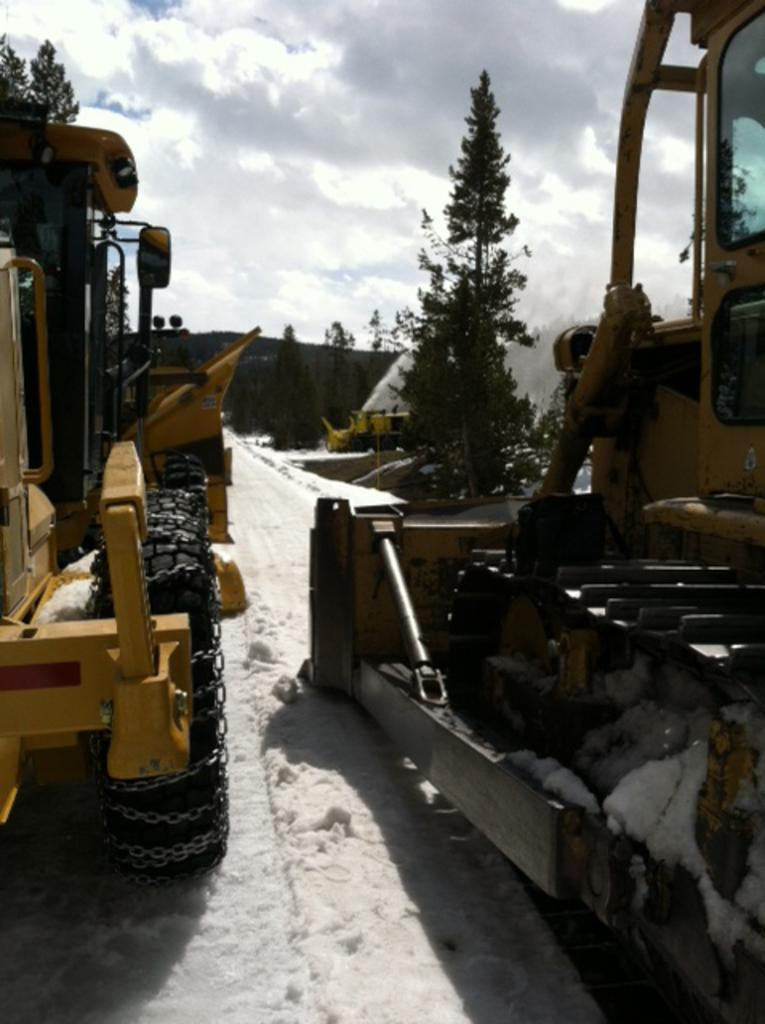What type of vehicles are in the image? There are two cranes in the image. Where are the cranes located? The cranes are on a snow road. What can be seen on either side of the road? There are trees on either side of the road. What is visible in the background of the image? The sky is visible in the image, and clouds are present in the sky. What type of design can be seen on the farm in the image? There is no farm present in the image, and therefore no design can be observed. How many bits are visible on the cranes in the image? Cranes do not have bits; they are construction vehicles with hooks or other lifting mechanisms. 